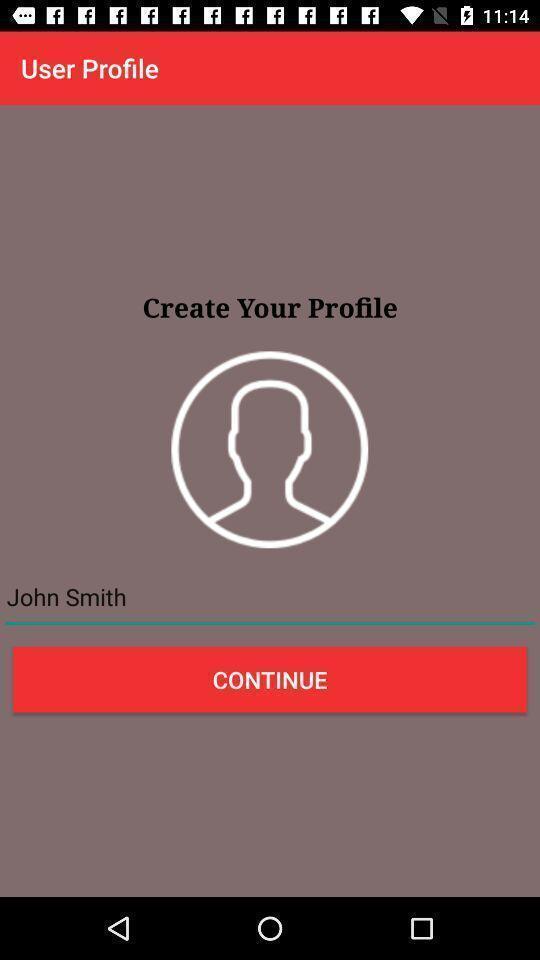Describe this image in words. Screen displaying the option to create profile. 